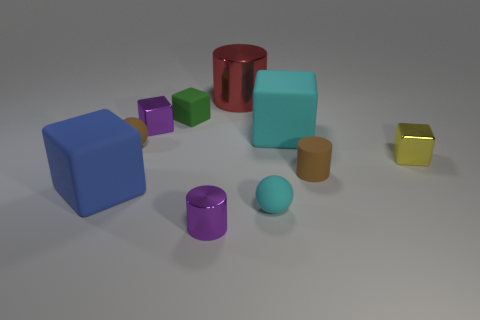What is the shape of the small metal object that is the same color as the tiny metallic cylinder?
Provide a short and direct response. Cube. Is the number of large blue objects that are to the right of the purple cylinder greater than the number of tiny green matte things?
Your answer should be very brief. No. Is the yellow cube made of the same material as the small green thing?
Provide a short and direct response. No. What number of things are large cubes that are to the left of the red cylinder or gray shiny objects?
Offer a very short reply. 1. What number of other objects are the same size as the brown cylinder?
Offer a terse response. 6. Are there the same number of purple blocks that are to the left of the red cylinder and big things to the left of the large blue object?
Your answer should be very brief. No. The other small matte thing that is the same shape as the red thing is what color?
Your response must be concise. Brown. Are there any other things that are the same shape as the tiny green object?
Your answer should be very brief. Yes. Is the color of the large matte thing that is left of the small green matte object the same as the big metallic thing?
Ensure brevity in your answer.  No. What size is the other metal thing that is the same shape as the small yellow thing?
Offer a very short reply. Small. 